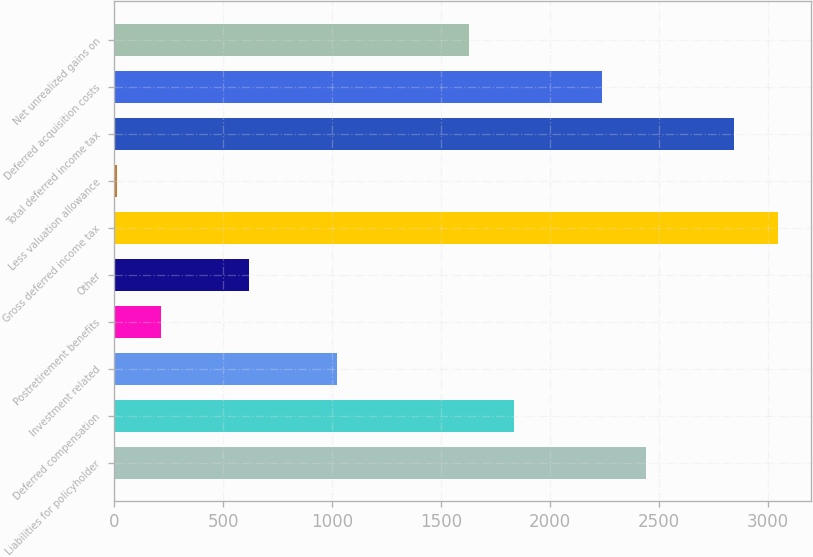Convert chart to OTSL. <chart><loc_0><loc_0><loc_500><loc_500><bar_chart><fcel>Liabilities for policyholder<fcel>Deferred compensation<fcel>Investment related<fcel>Postretirement benefits<fcel>Other<fcel>Gross deferred income tax<fcel>Less valuation allowance<fcel>Total deferred income tax<fcel>Deferred acquisition costs<fcel>Net unrealized gains on<nl><fcel>2441<fcel>1833.5<fcel>1023.5<fcel>213.5<fcel>618.5<fcel>3048.5<fcel>11<fcel>2846<fcel>2238.5<fcel>1631<nl></chart> 